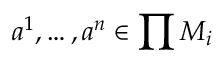Convert formula to latex. <formula><loc_0><loc_0><loc_500><loc_500>a ^ { 1 } , \dots , a ^ { n } \in \prod M _ { i }</formula> 